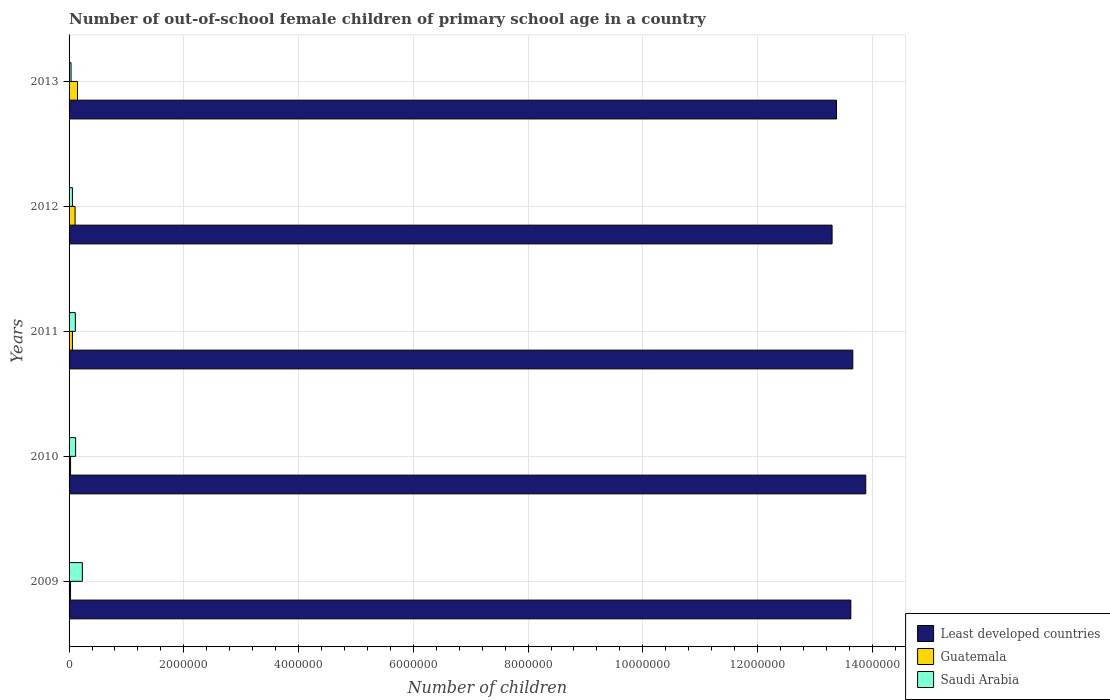How many different coloured bars are there?
Provide a short and direct response. 3. How many groups of bars are there?
Offer a very short reply. 5. How many bars are there on the 1st tick from the top?
Your answer should be very brief. 3. How many bars are there on the 5th tick from the bottom?
Provide a succinct answer. 3. In how many cases, is the number of bars for a given year not equal to the number of legend labels?
Your response must be concise. 0. What is the number of out-of-school female children in Least developed countries in 2009?
Your answer should be compact. 1.36e+07. Across all years, what is the maximum number of out-of-school female children in Least developed countries?
Offer a very short reply. 1.39e+07. Across all years, what is the minimum number of out-of-school female children in Least developed countries?
Offer a terse response. 1.33e+07. What is the total number of out-of-school female children in Least developed countries in the graph?
Make the answer very short. 6.78e+07. What is the difference between the number of out-of-school female children in Least developed countries in 2011 and that in 2012?
Keep it short and to the point. 3.61e+05. What is the difference between the number of out-of-school female children in Saudi Arabia in 2009 and the number of out-of-school female children in Least developed countries in 2011?
Your answer should be very brief. -1.34e+07. What is the average number of out-of-school female children in Saudi Arabia per year?
Your response must be concise. 1.10e+05. In the year 2011, what is the difference between the number of out-of-school female children in Least developed countries and number of out-of-school female children in Guatemala?
Your answer should be compact. 1.36e+07. What is the ratio of the number of out-of-school female children in Least developed countries in 2010 to that in 2012?
Offer a terse response. 1.04. Is the difference between the number of out-of-school female children in Least developed countries in 2009 and 2011 greater than the difference between the number of out-of-school female children in Guatemala in 2009 and 2011?
Ensure brevity in your answer.  No. What is the difference between the highest and the second highest number of out-of-school female children in Least developed countries?
Ensure brevity in your answer.  2.26e+05. What is the difference between the highest and the lowest number of out-of-school female children in Least developed countries?
Offer a very short reply. 5.87e+05. In how many years, is the number of out-of-school female children in Least developed countries greater than the average number of out-of-school female children in Least developed countries taken over all years?
Provide a succinct answer. 3. Is the sum of the number of out-of-school female children in Saudi Arabia in 2010 and 2011 greater than the maximum number of out-of-school female children in Guatemala across all years?
Keep it short and to the point. Yes. What does the 1st bar from the top in 2009 represents?
Offer a very short reply. Saudi Arabia. What does the 2nd bar from the bottom in 2010 represents?
Keep it short and to the point. Guatemala. How many bars are there?
Make the answer very short. 15. Are all the bars in the graph horizontal?
Ensure brevity in your answer.  Yes. Does the graph contain grids?
Keep it short and to the point. Yes. How many legend labels are there?
Offer a terse response. 3. How are the legend labels stacked?
Your answer should be very brief. Vertical. What is the title of the graph?
Ensure brevity in your answer.  Number of out-of-school female children of primary school age in a country. What is the label or title of the X-axis?
Offer a very short reply. Number of children. What is the Number of children in Least developed countries in 2009?
Your answer should be very brief. 1.36e+07. What is the Number of children of Guatemala in 2009?
Provide a succinct answer. 2.59e+04. What is the Number of children of Saudi Arabia in 2009?
Ensure brevity in your answer.  2.32e+05. What is the Number of children of Least developed countries in 2010?
Your answer should be very brief. 1.39e+07. What is the Number of children of Guatemala in 2010?
Provide a succinct answer. 2.60e+04. What is the Number of children of Saudi Arabia in 2010?
Offer a terse response. 1.14e+05. What is the Number of children of Least developed countries in 2011?
Keep it short and to the point. 1.37e+07. What is the Number of children of Guatemala in 2011?
Ensure brevity in your answer.  5.87e+04. What is the Number of children in Saudi Arabia in 2011?
Keep it short and to the point. 1.09e+05. What is the Number of children in Least developed countries in 2012?
Provide a short and direct response. 1.33e+07. What is the Number of children in Guatemala in 2012?
Offer a very short reply. 1.05e+05. What is the Number of children in Saudi Arabia in 2012?
Make the answer very short. 5.86e+04. What is the Number of children of Least developed countries in 2013?
Provide a succinct answer. 1.34e+07. What is the Number of children in Guatemala in 2013?
Offer a terse response. 1.47e+05. What is the Number of children in Saudi Arabia in 2013?
Make the answer very short. 3.47e+04. Across all years, what is the maximum Number of children in Least developed countries?
Offer a very short reply. 1.39e+07. Across all years, what is the maximum Number of children in Guatemala?
Your answer should be very brief. 1.47e+05. Across all years, what is the maximum Number of children in Saudi Arabia?
Keep it short and to the point. 2.32e+05. Across all years, what is the minimum Number of children in Least developed countries?
Offer a very short reply. 1.33e+07. Across all years, what is the minimum Number of children of Guatemala?
Provide a short and direct response. 2.59e+04. Across all years, what is the minimum Number of children in Saudi Arabia?
Make the answer very short. 3.47e+04. What is the total Number of children in Least developed countries in the graph?
Offer a very short reply. 6.78e+07. What is the total Number of children of Guatemala in the graph?
Keep it short and to the point. 3.62e+05. What is the total Number of children of Saudi Arabia in the graph?
Your answer should be very brief. 5.48e+05. What is the difference between the Number of children of Least developed countries in 2009 and that in 2010?
Offer a very short reply. -2.60e+05. What is the difference between the Number of children in Guatemala in 2009 and that in 2010?
Give a very brief answer. -110. What is the difference between the Number of children in Saudi Arabia in 2009 and that in 2010?
Give a very brief answer. 1.18e+05. What is the difference between the Number of children in Least developed countries in 2009 and that in 2011?
Make the answer very short. -3.42e+04. What is the difference between the Number of children in Guatemala in 2009 and that in 2011?
Your answer should be very brief. -3.29e+04. What is the difference between the Number of children of Saudi Arabia in 2009 and that in 2011?
Keep it short and to the point. 1.22e+05. What is the difference between the Number of children in Least developed countries in 2009 and that in 2012?
Provide a short and direct response. 3.27e+05. What is the difference between the Number of children in Guatemala in 2009 and that in 2012?
Ensure brevity in your answer.  -7.90e+04. What is the difference between the Number of children of Saudi Arabia in 2009 and that in 2012?
Offer a terse response. 1.73e+05. What is the difference between the Number of children of Least developed countries in 2009 and that in 2013?
Provide a short and direct response. 2.50e+05. What is the difference between the Number of children of Guatemala in 2009 and that in 2013?
Provide a short and direct response. -1.21e+05. What is the difference between the Number of children of Saudi Arabia in 2009 and that in 2013?
Offer a very short reply. 1.97e+05. What is the difference between the Number of children of Least developed countries in 2010 and that in 2011?
Your answer should be compact. 2.26e+05. What is the difference between the Number of children of Guatemala in 2010 and that in 2011?
Provide a succinct answer. -3.28e+04. What is the difference between the Number of children of Saudi Arabia in 2010 and that in 2011?
Your answer should be compact. 4627. What is the difference between the Number of children of Least developed countries in 2010 and that in 2012?
Provide a succinct answer. 5.87e+05. What is the difference between the Number of children in Guatemala in 2010 and that in 2012?
Your answer should be very brief. -7.89e+04. What is the difference between the Number of children in Saudi Arabia in 2010 and that in 2012?
Make the answer very short. 5.54e+04. What is the difference between the Number of children of Least developed countries in 2010 and that in 2013?
Ensure brevity in your answer.  5.09e+05. What is the difference between the Number of children in Guatemala in 2010 and that in 2013?
Offer a terse response. -1.21e+05. What is the difference between the Number of children in Saudi Arabia in 2010 and that in 2013?
Provide a succinct answer. 7.93e+04. What is the difference between the Number of children of Least developed countries in 2011 and that in 2012?
Provide a succinct answer. 3.61e+05. What is the difference between the Number of children in Guatemala in 2011 and that in 2012?
Your answer should be very brief. -4.61e+04. What is the difference between the Number of children of Saudi Arabia in 2011 and that in 2012?
Offer a terse response. 5.08e+04. What is the difference between the Number of children of Least developed countries in 2011 and that in 2013?
Offer a terse response. 2.84e+05. What is the difference between the Number of children of Guatemala in 2011 and that in 2013?
Your answer should be compact. -8.81e+04. What is the difference between the Number of children of Saudi Arabia in 2011 and that in 2013?
Offer a very short reply. 7.47e+04. What is the difference between the Number of children in Least developed countries in 2012 and that in 2013?
Give a very brief answer. -7.73e+04. What is the difference between the Number of children in Guatemala in 2012 and that in 2013?
Your answer should be compact. -4.20e+04. What is the difference between the Number of children of Saudi Arabia in 2012 and that in 2013?
Offer a terse response. 2.39e+04. What is the difference between the Number of children in Least developed countries in 2009 and the Number of children in Guatemala in 2010?
Offer a very short reply. 1.36e+07. What is the difference between the Number of children of Least developed countries in 2009 and the Number of children of Saudi Arabia in 2010?
Provide a succinct answer. 1.35e+07. What is the difference between the Number of children of Guatemala in 2009 and the Number of children of Saudi Arabia in 2010?
Give a very brief answer. -8.82e+04. What is the difference between the Number of children of Least developed countries in 2009 and the Number of children of Guatemala in 2011?
Offer a terse response. 1.36e+07. What is the difference between the Number of children of Least developed countries in 2009 and the Number of children of Saudi Arabia in 2011?
Your answer should be very brief. 1.35e+07. What is the difference between the Number of children in Guatemala in 2009 and the Number of children in Saudi Arabia in 2011?
Keep it short and to the point. -8.35e+04. What is the difference between the Number of children in Least developed countries in 2009 and the Number of children in Guatemala in 2012?
Keep it short and to the point. 1.35e+07. What is the difference between the Number of children in Least developed countries in 2009 and the Number of children in Saudi Arabia in 2012?
Offer a very short reply. 1.36e+07. What is the difference between the Number of children in Guatemala in 2009 and the Number of children in Saudi Arabia in 2012?
Make the answer very short. -3.27e+04. What is the difference between the Number of children in Least developed countries in 2009 and the Number of children in Guatemala in 2013?
Give a very brief answer. 1.35e+07. What is the difference between the Number of children of Least developed countries in 2009 and the Number of children of Saudi Arabia in 2013?
Your answer should be very brief. 1.36e+07. What is the difference between the Number of children in Guatemala in 2009 and the Number of children in Saudi Arabia in 2013?
Provide a succinct answer. -8827. What is the difference between the Number of children in Least developed countries in 2010 and the Number of children in Guatemala in 2011?
Provide a succinct answer. 1.38e+07. What is the difference between the Number of children of Least developed countries in 2010 and the Number of children of Saudi Arabia in 2011?
Give a very brief answer. 1.38e+07. What is the difference between the Number of children in Guatemala in 2010 and the Number of children in Saudi Arabia in 2011?
Provide a succinct answer. -8.34e+04. What is the difference between the Number of children in Least developed countries in 2010 and the Number of children in Guatemala in 2012?
Offer a very short reply. 1.38e+07. What is the difference between the Number of children of Least developed countries in 2010 and the Number of children of Saudi Arabia in 2012?
Offer a terse response. 1.38e+07. What is the difference between the Number of children of Guatemala in 2010 and the Number of children of Saudi Arabia in 2012?
Provide a short and direct response. -3.26e+04. What is the difference between the Number of children in Least developed countries in 2010 and the Number of children in Guatemala in 2013?
Your answer should be very brief. 1.37e+07. What is the difference between the Number of children of Least developed countries in 2010 and the Number of children of Saudi Arabia in 2013?
Offer a very short reply. 1.39e+07. What is the difference between the Number of children of Guatemala in 2010 and the Number of children of Saudi Arabia in 2013?
Your answer should be compact. -8717. What is the difference between the Number of children in Least developed countries in 2011 and the Number of children in Guatemala in 2012?
Your response must be concise. 1.36e+07. What is the difference between the Number of children of Least developed countries in 2011 and the Number of children of Saudi Arabia in 2012?
Provide a succinct answer. 1.36e+07. What is the difference between the Number of children of Guatemala in 2011 and the Number of children of Saudi Arabia in 2012?
Ensure brevity in your answer.  169. What is the difference between the Number of children of Least developed countries in 2011 and the Number of children of Guatemala in 2013?
Provide a succinct answer. 1.35e+07. What is the difference between the Number of children of Least developed countries in 2011 and the Number of children of Saudi Arabia in 2013?
Provide a succinct answer. 1.36e+07. What is the difference between the Number of children of Guatemala in 2011 and the Number of children of Saudi Arabia in 2013?
Offer a terse response. 2.41e+04. What is the difference between the Number of children in Least developed countries in 2012 and the Number of children in Guatemala in 2013?
Provide a short and direct response. 1.32e+07. What is the difference between the Number of children of Least developed countries in 2012 and the Number of children of Saudi Arabia in 2013?
Provide a succinct answer. 1.33e+07. What is the difference between the Number of children of Guatemala in 2012 and the Number of children of Saudi Arabia in 2013?
Your answer should be very brief. 7.02e+04. What is the average Number of children in Least developed countries per year?
Offer a very short reply. 1.36e+07. What is the average Number of children of Guatemala per year?
Provide a short and direct response. 7.24e+04. What is the average Number of children in Saudi Arabia per year?
Offer a very short reply. 1.10e+05. In the year 2009, what is the difference between the Number of children in Least developed countries and Number of children in Guatemala?
Make the answer very short. 1.36e+07. In the year 2009, what is the difference between the Number of children of Least developed countries and Number of children of Saudi Arabia?
Make the answer very short. 1.34e+07. In the year 2009, what is the difference between the Number of children of Guatemala and Number of children of Saudi Arabia?
Ensure brevity in your answer.  -2.06e+05. In the year 2010, what is the difference between the Number of children of Least developed countries and Number of children of Guatemala?
Provide a short and direct response. 1.39e+07. In the year 2010, what is the difference between the Number of children in Least developed countries and Number of children in Saudi Arabia?
Your answer should be compact. 1.38e+07. In the year 2010, what is the difference between the Number of children of Guatemala and Number of children of Saudi Arabia?
Keep it short and to the point. -8.81e+04. In the year 2011, what is the difference between the Number of children of Least developed countries and Number of children of Guatemala?
Offer a very short reply. 1.36e+07. In the year 2011, what is the difference between the Number of children of Least developed countries and Number of children of Saudi Arabia?
Your answer should be compact. 1.36e+07. In the year 2011, what is the difference between the Number of children in Guatemala and Number of children in Saudi Arabia?
Offer a terse response. -5.07e+04. In the year 2012, what is the difference between the Number of children of Least developed countries and Number of children of Guatemala?
Provide a short and direct response. 1.32e+07. In the year 2012, what is the difference between the Number of children of Least developed countries and Number of children of Saudi Arabia?
Your response must be concise. 1.32e+07. In the year 2012, what is the difference between the Number of children in Guatemala and Number of children in Saudi Arabia?
Your answer should be very brief. 4.63e+04. In the year 2013, what is the difference between the Number of children of Least developed countries and Number of children of Guatemala?
Keep it short and to the point. 1.32e+07. In the year 2013, what is the difference between the Number of children in Least developed countries and Number of children in Saudi Arabia?
Keep it short and to the point. 1.33e+07. In the year 2013, what is the difference between the Number of children of Guatemala and Number of children of Saudi Arabia?
Ensure brevity in your answer.  1.12e+05. What is the ratio of the Number of children of Least developed countries in 2009 to that in 2010?
Provide a succinct answer. 0.98. What is the ratio of the Number of children in Guatemala in 2009 to that in 2010?
Keep it short and to the point. 1. What is the ratio of the Number of children in Saudi Arabia in 2009 to that in 2010?
Your response must be concise. 2.03. What is the ratio of the Number of children in Guatemala in 2009 to that in 2011?
Provide a short and direct response. 0.44. What is the ratio of the Number of children of Saudi Arabia in 2009 to that in 2011?
Give a very brief answer. 2.12. What is the ratio of the Number of children of Least developed countries in 2009 to that in 2012?
Your response must be concise. 1.02. What is the ratio of the Number of children in Guatemala in 2009 to that in 2012?
Your answer should be very brief. 0.25. What is the ratio of the Number of children of Saudi Arabia in 2009 to that in 2012?
Make the answer very short. 3.96. What is the ratio of the Number of children in Least developed countries in 2009 to that in 2013?
Offer a terse response. 1.02. What is the ratio of the Number of children of Guatemala in 2009 to that in 2013?
Give a very brief answer. 0.18. What is the ratio of the Number of children of Saudi Arabia in 2009 to that in 2013?
Provide a succinct answer. 6.68. What is the ratio of the Number of children in Least developed countries in 2010 to that in 2011?
Provide a short and direct response. 1.02. What is the ratio of the Number of children in Guatemala in 2010 to that in 2011?
Give a very brief answer. 0.44. What is the ratio of the Number of children in Saudi Arabia in 2010 to that in 2011?
Your response must be concise. 1.04. What is the ratio of the Number of children of Least developed countries in 2010 to that in 2012?
Give a very brief answer. 1.04. What is the ratio of the Number of children in Guatemala in 2010 to that in 2012?
Offer a terse response. 0.25. What is the ratio of the Number of children in Saudi Arabia in 2010 to that in 2012?
Your answer should be very brief. 1.95. What is the ratio of the Number of children of Least developed countries in 2010 to that in 2013?
Give a very brief answer. 1.04. What is the ratio of the Number of children in Guatemala in 2010 to that in 2013?
Provide a short and direct response. 0.18. What is the ratio of the Number of children of Saudi Arabia in 2010 to that in 2013?
Give a very brief answer. 3.29. What is the ratio of the Number of children of Least developed countries in 2011 to that in 2012?
Make the answer very short. 1.03. What is the ratio of the Number of children of Guatemala in 2011 to that in 2012?
Make the answer very short. 0.56. What is the ratio of the Number of children of Saudi Arabia in 2011 to that in 2012?
Offer a very short reply. 1.87. What is the ratio of the Number of children of Least developed countries in 2011 to that in 2013?
Offer a terse response. 1.02. What is the ratio of the Number of children in Guatemala in 2011 to that in 2013?
Offer a terse response. 0.4. What is the ratio of the Number of children of Saudi Arabia in 2011 to that in 2013?
Provide a short and direct response. 3.15. What is the ratio of the Number of children in Guatemala in 2012 to that in 2013?
Offer a terse response. 0.71. What is the ratio of the Number of children in Saudi Arabia in 2012 to that in 2013?
Provide a short and direct response. 1.69. What is the difference between the highest and the second highest Number of children of Least developed countries?
Offer a very short reply. 2.26e+05. What is the difference between the highest and the second highest Number of children in Guatemala?
Ensure brevity in your answer.  4.20e+04. What is the difference between the highest and the second highest Number of children of Saudi Arabia?
Offer a very short reply. 1.18e+05. What is the difference between the highest and the lowest Number of children in Least developed countries?
Offer a very short reply. 5.87e+05. What is the difference between the highest and the lowest Number of children of Guatemala?
Your answer should be compact. 1.21e+05. What is the difference between the highest and the lowest Number of children of Saudi Arabia?
Provide a succinct answer. 1.97e+05. 